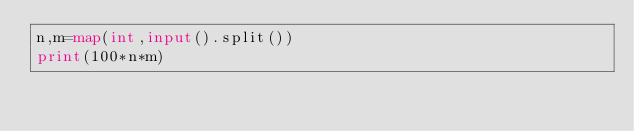Convert code to text. <code><loc_0><loc_0><loc_500><loc_500><_Python_>n,m=map(int,input().split())
print(100*n*m)
</code> 